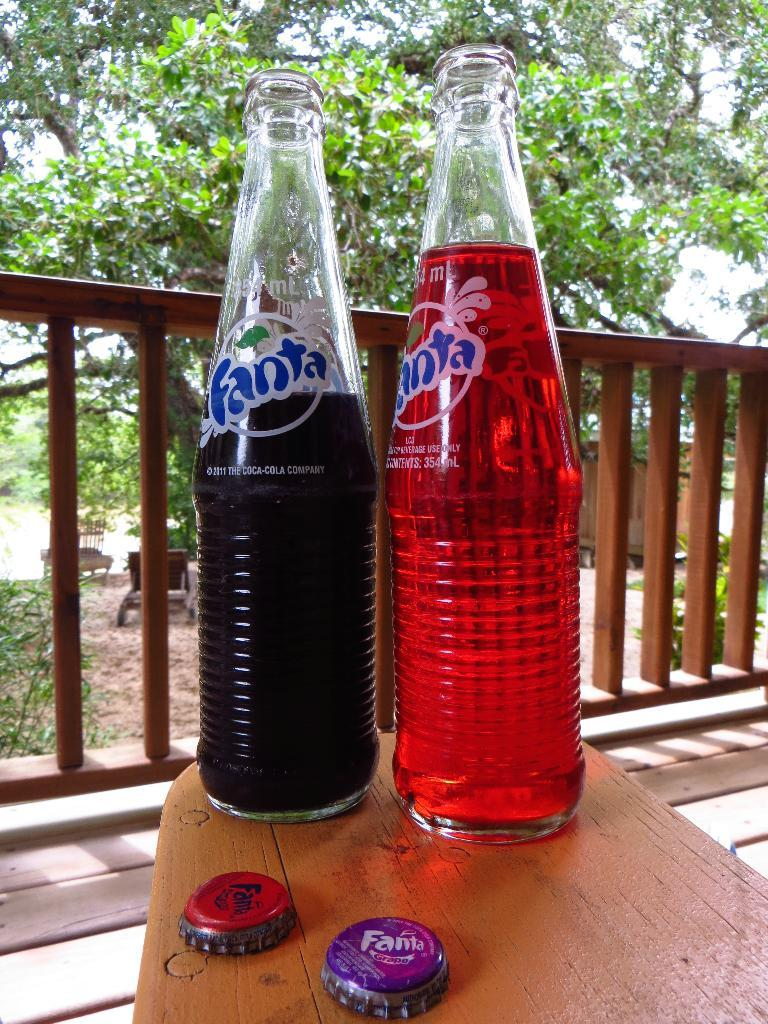<image>
Offer a succinct explanation of the picture presented. a bottle of grape fanta standing next to a bottle of strawberry fanta on a table 